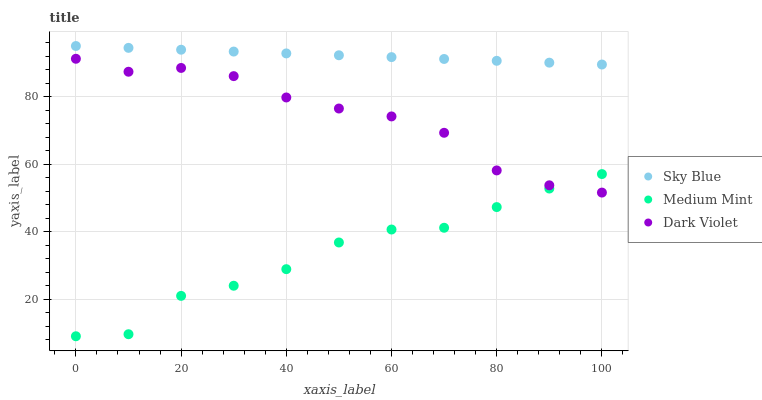Does Medium Mint have the minimum area under the curve?
Answer yes or no. Yes. Does Sky Blue have the maximum area under the curve?
Answer yes or no. Yes. Does Dark Violet have the minimum area under the curve?
Answer yes or no. No. Does Dark Violet have the maximum area under the curve?
Answer yes or no. No. Is Sky Blue the smoothest?
Answer yes or no. Yes. Is Medium Mint the roughest?
Answer yes or no. Yes. Is Dark Violet the smoothest?
Answer yes or no. No. Is Dark Violet the roughest?
Answer yes or no. No. Does Medium Mint have the lowest value?
Answer yes or no. Yes. Does Dark Violet have the lowest value?
Answer yes or no. No. Does Sky Blue have the highest value?
Answer yes or no. Yes. Does Dark Violet have the highest value?
Answer yes or no. No. Is Dark Violet less than Sky Blue?
Answer yes or no. Yes. Is Sky Blue greater than Dark Violet?
Answer yes or no. Yes. Does Dark Violet intersect Medium Mint?
Answer yes or no. Yes. Is Dark Violet less than Medium Mint?
Answer yes or no. No. Is Dark Violet greater than Medium Mint?
Answer yes or no. No. Does Dark Violet intersect Sky Blue?
Answer yes or no. No. 